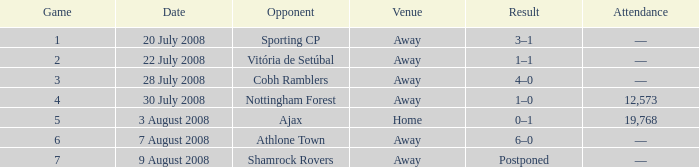What happens in a game with a game number higher than 6 and hosted at an away location? Postponed. 